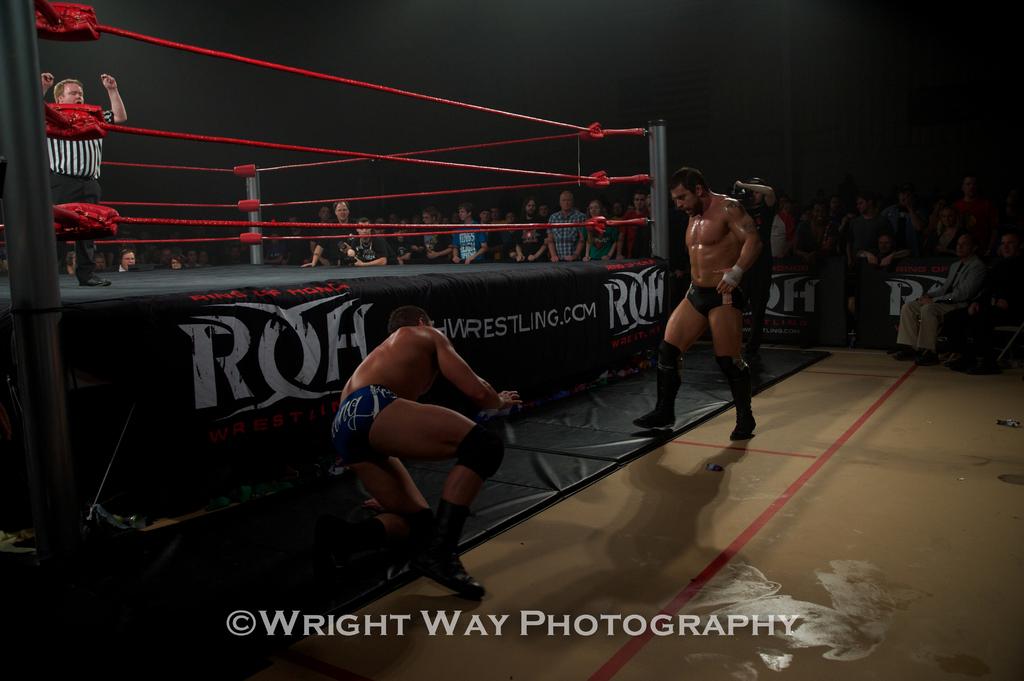What is the first letter of the large word on the side of the ring?
Offer a very short reply. R. 